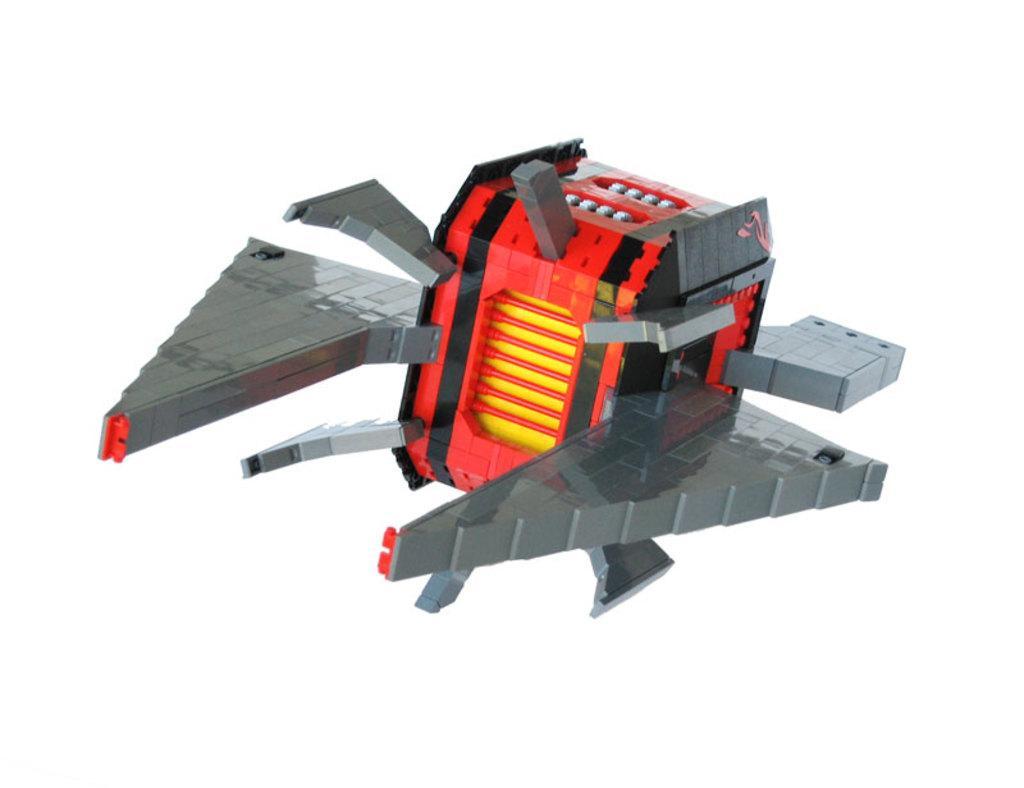Please provide a concise description of this image. In this image we can see a toy, and the background is white in color. 